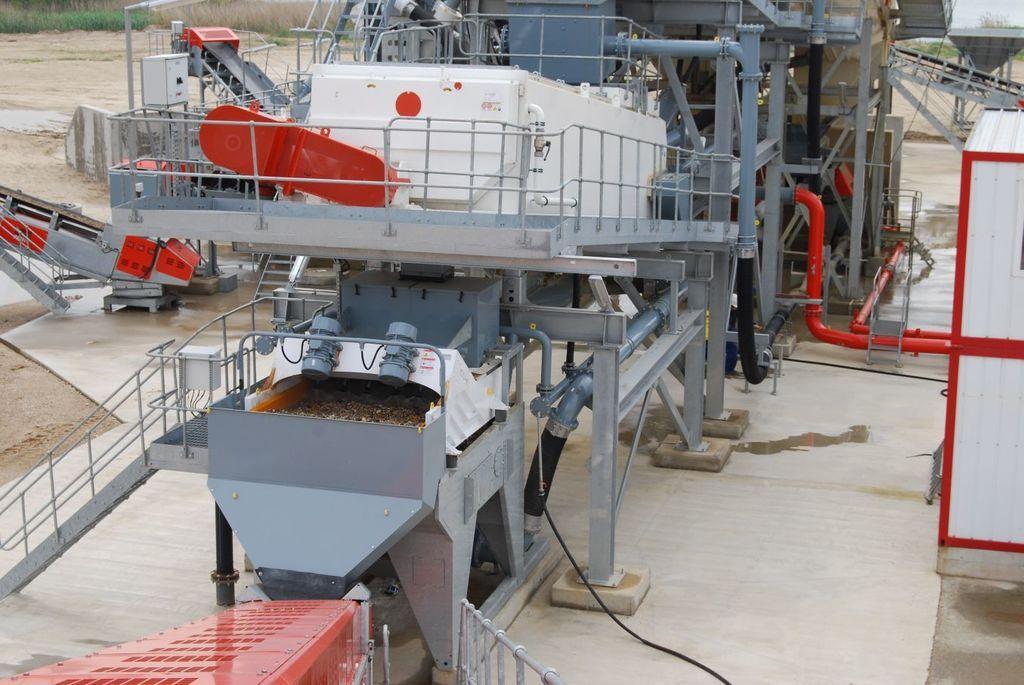Please provide a concise description of this image. In the center of the image we can see some machines with pipes railings. In the background, we can see the grass and sand. 